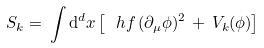Convert formula to latex. <formula><loc_0><loc_0><loc_500><loc_500>S _ { k } = \, \int { \mathrm d } ^ { d } x \left [ \ h f \, ( \partial _ { \mu } \phi ) ^ { 2 } \, + \, V _ { k } ( \phi ) \right ]</formula> 